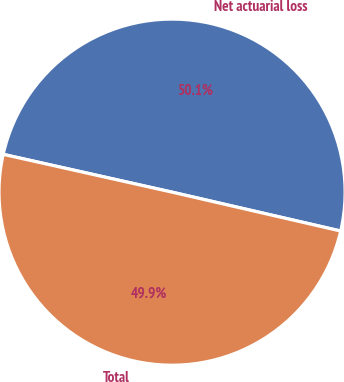<chart> <loc_0><loc_0><loc_500><loc_500><pie_chart><fcel>Net actuarial loss<fcel>Total<nl><fcel>50.1%<fcel>49.9%<nl></chart> 